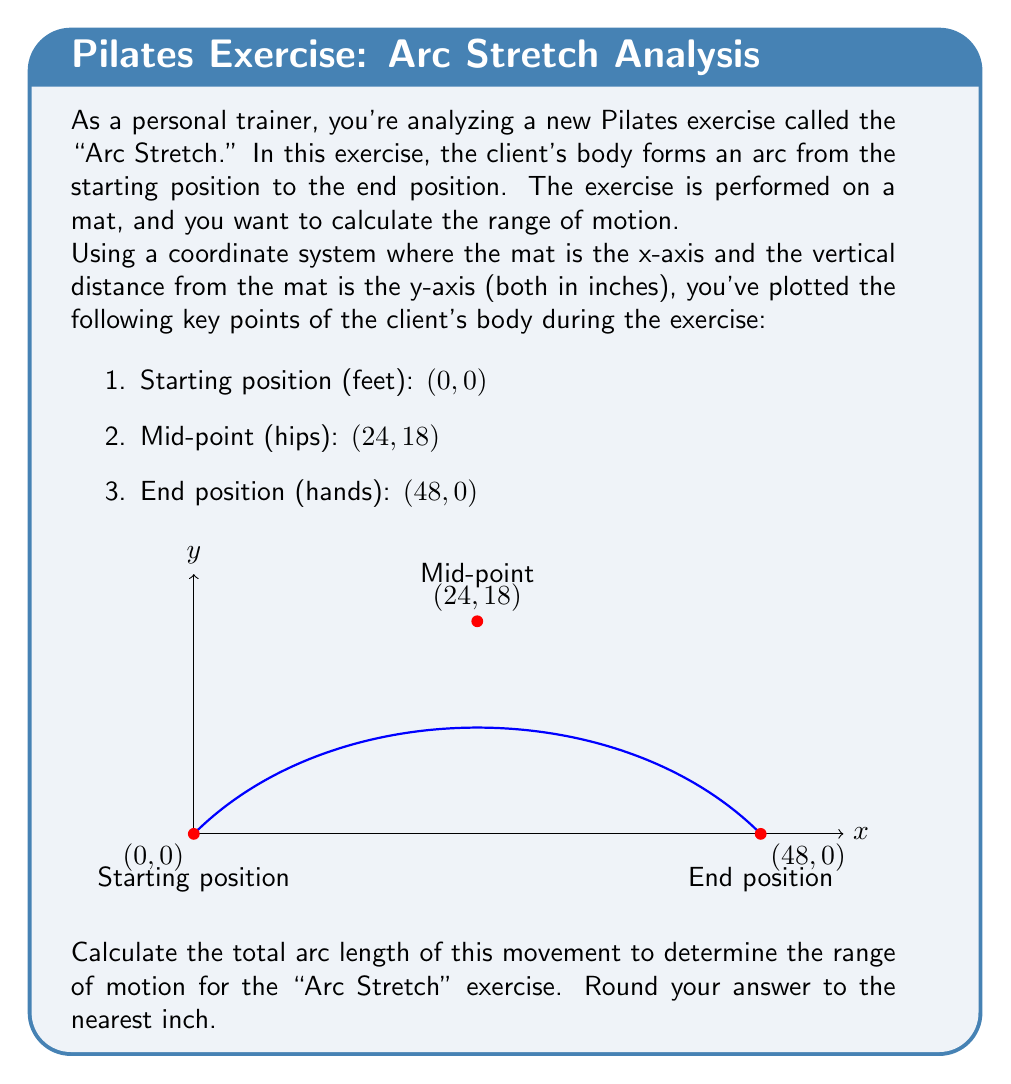Could you help me with this problem? To calculate the arc length, we'll use the formula for the length of a parabolic arc, as the movement forms a parabolic shape. The steps are as follows:

1) First, we need to find the equation of the parabola that passes through these three points. The general form of a parabola is $y = ax^2 + bx + c$.

2) Using the three points, we can set up a system of equations:
   $0 = a(0)^2 + b(0) + c$
   $18 = a(24)^2 + b(24) + c$
   $0 = a(48)^2 + b(48) + c$

3) Solving this system (which can be done using substitution or matrix methods), we get:
   $a = -\frac{1}{32}$, $b = \frac{3}{4}$, $c = 0$

4) So, our parabola equation is: $y = -\frac{1}{32}x^2 + \frac{3}{4}x$

5) The formula for the length of a parabolic arc from $x=a$ to $x=b$ is:

   $$L = \int_{a}^{b} \sqrt{1 + [f'(x)]^2} dx$$

   where $f'(x)$ is the derivative of our parabola equation.

6) $f'(x) = -\frac{1}{16}x + \frac{3}{4}$

7) Substituting into the arc length formula:

   $$L = \int_{0}^{48} \sqrt{1 + (-\frac{1}{16}x + \frac{3}{4})^2} dx$$

8) This integral is complex and typically solved numerically. Using a calculator or computer algebra system, we get:

   $L \approx 51.94$ inches

9) Rounding to the nearest inch, we get 52 inches.
Answer: 52 inches 